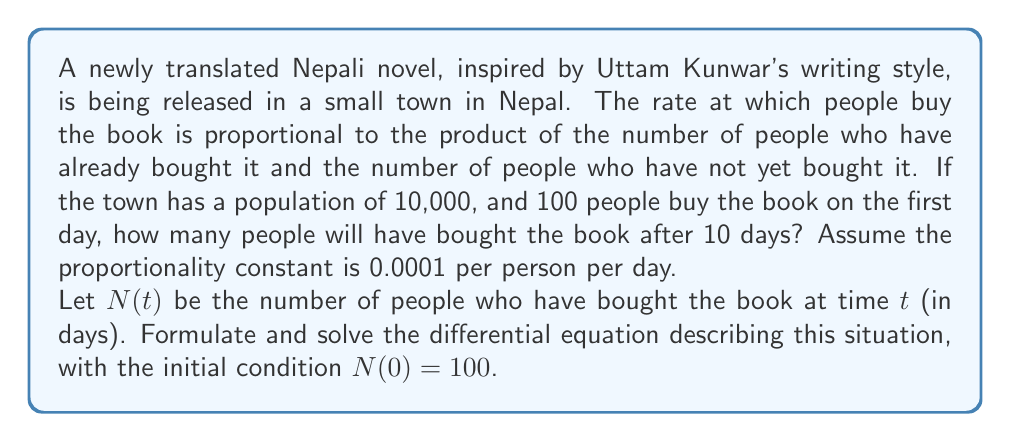What is the answer to this math problem? Let's approach this step-by-step:

1) First, we need to formulate the differential equation. The rate of change of N(t) is proportional to N(t) and (10000 - N(t)):

   $$\frac{dN}{dt} = k N(t) (10000 - N(t))$$

   where k = 0.0001 is the proportionality constant.

2) This is a separable differential equation. Let's separate the variables:

   $$\frac{dN}{N(10000 - N)} = 0.0001 dt$$

3) Integrate both sides:

   $$\int \frac{dN}{N(10000 - N)} = \int 0.0001 dt$$

4) The left side can be integrated using partial fractions:

   $$\frac{1}{10000} \ln|\frac{N}{10000-N}| = 0.0001t + C$$

5) Now, let's use the initial condition N(0) = 100 to find C:

   $$\frac{1}{10000} \ln|\frac{100}{9900}| = C$$

6) Substitute this back into our equation:

   $$\frac{1}{10000} \ln|\frac{N}{10000-N}| = 0.0001t + \frac{1}{10000} \ln|\frac{100}{9900}|$$

7) Simplify:

   $$\ln|\frac{N}{10000-N}| = t + \ln|\frac{100}{9900}|$$

8) Exponentiate both sides:

   $$\frac{N}{10000-N} = e^t \cdot \frac{100}{9900}$$

9) Solve for N:

   $$N = \frac{1000000e^t}{99 + e^t}$$

10) Now, we can find N(10) by substituting t = 10:

    $$N(10) = \frac{1000000e^{10}}{99 + e^{10}} \approx 9978$$
Answer: After 10 days, approximately 9,978 people will have bought the book. 